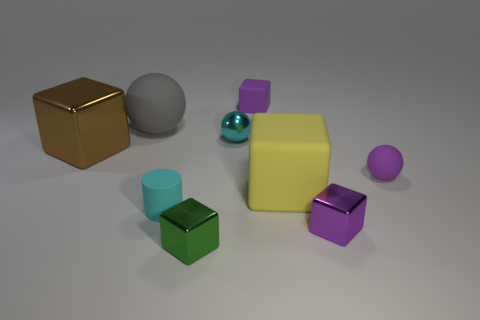Do the tiny metallic object behind the purple metal object and the small matte cylinder have the same color?
Offer a terse response. Yes. Is the number of purple cubes that are on the right side of the cyan metallic sphere greater than the number of purple spheres?
Make the answer very short. Yes. How many objects are gray objects or purple cubes in front of the yellow rubber object?
Your answer should be compact. 2. Are there more small matte blocks behind the green object than tiny matte cubes in front of the yellow matte object?
Make the answer very short. Yes. There is a purple sphere right of the small purple rubber thing behind the rubber thing on the right side of the big yellow thing; what is its material?
Your answer should be very brief. Rubber. The green thing that is the same material as the big brown block is what shape?
Ensure brevity in your answer.  Cube. Is there a block right of the shiny cube that is left of the big ball?
Your response must be concise. Yes. What is the size of the gray matte ball?
Give a very brief answer. Large. What number of objects are tiny purple matte cubes or small cyan metal objects?
Your response must be concise. 2. Are the cube left of the large gray matte object and the big block that is to the right of the green object made of the same material?
Your answer should be very brief. No. 